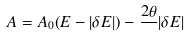<formula> <loc_0><loc_0><loc_500><loc_500>A = A _ { 0 } ( E - | \delta E | ) - \frac { 2 \theta } { } | \delta E |</formula> 